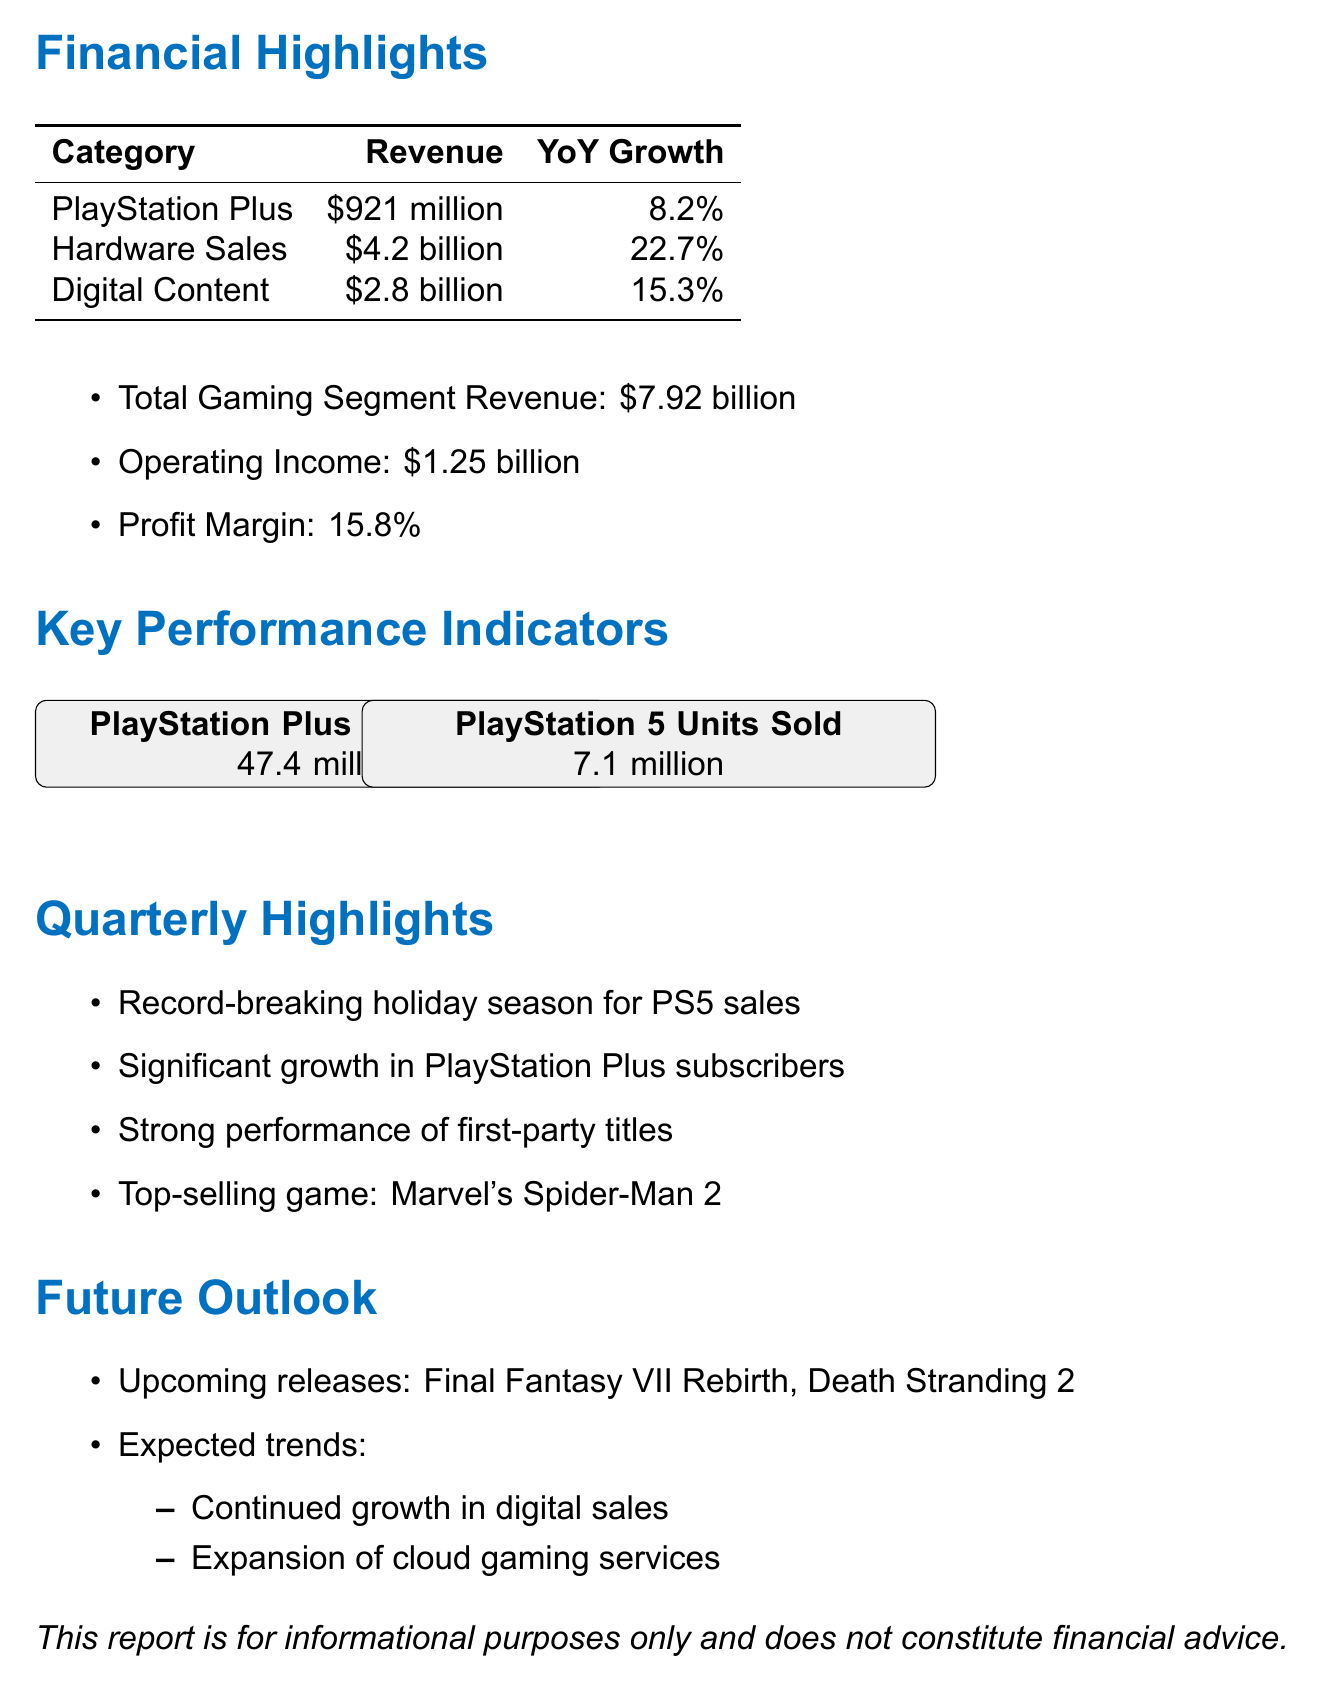What is the total subscription revenue? The total subscription revenue for PlayStation Plus is stated in the document, which is $921 million.
Answer: $921 million How many PlayStation 5 units were sold? The document specifies that 7.1 million PlayStation 5 units were sold in Q3 FY2023.
Answer: 7.1 million What is the year-over-year growth in digital content purchases? The document indicates that the year-over-year growth in digital content purchases is 15.3%.
Answer: 15.3% What is the profit margin? The profit margin, as stated in the financial summary, is 15.8%.
Answer: 15.8% What is the top-selling game? According to the document, the top-selling game for the quarter is Marvel's Spider-Man 2.
Answer: Marvel's Spider-Man 2 What was the total gaming segment revenue for Q3 FY2023? The total gaming segment revenue is summarized in the document as $7.92 billion.
Answer: $7.92 billion What are the expected trends mentioned in the future outlook? The document lists expected trends which include continued growth in digital sales and expansion of cloud gaming services.
Answer: Continued growth in digital sales, expansion of cloud gaming services What was the significant growth in PlayStation Plus subscribers year-over-year? The document reports that there was a significant growth of 8.2% in PlayStation Plus subscribers year-over-year.
Answer: 8.2% What upcoming releases are mentioned? The document mentions two upcoming releases: Final Fantasy VII Rebirth and Death Stranding 2.
Answer: Final Fantasy VII Rebirth, Death Stranding 2 